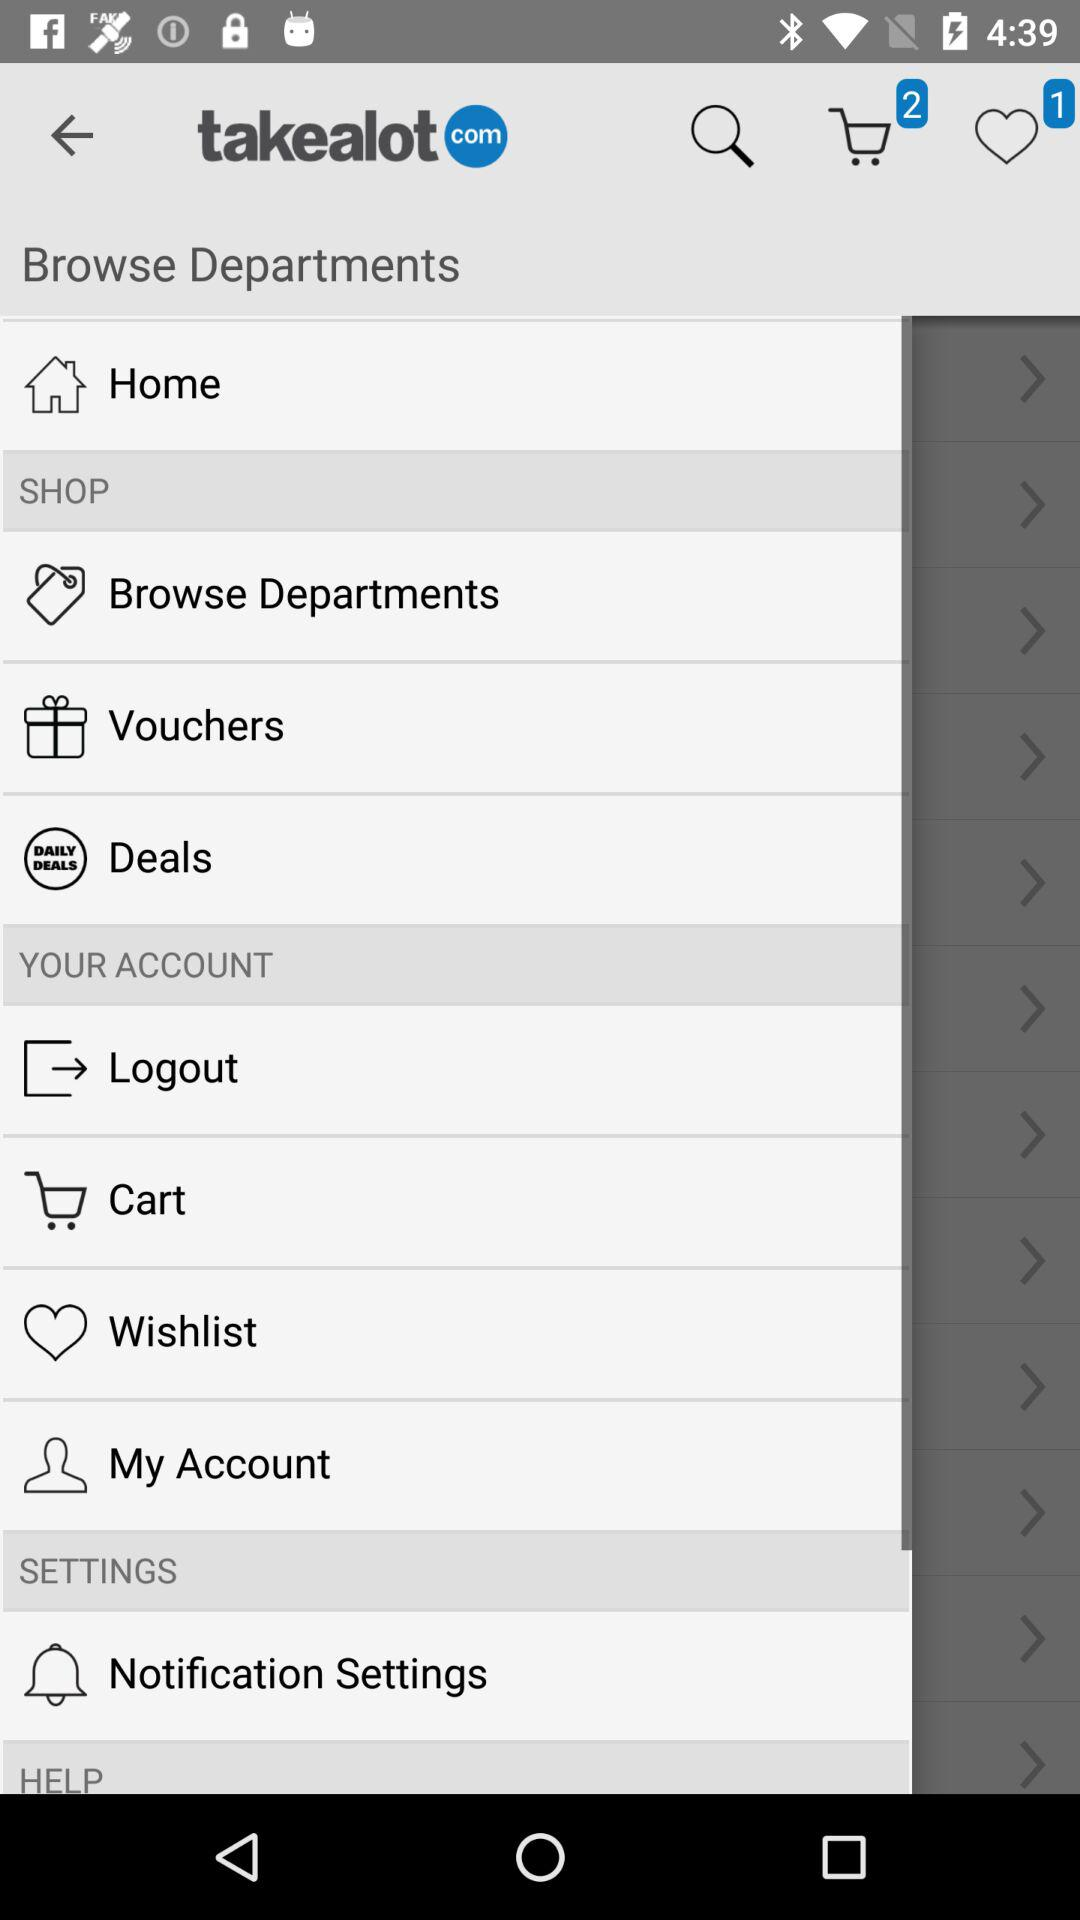How many favorites are there in "Takealot"? There is 1 favorite. 